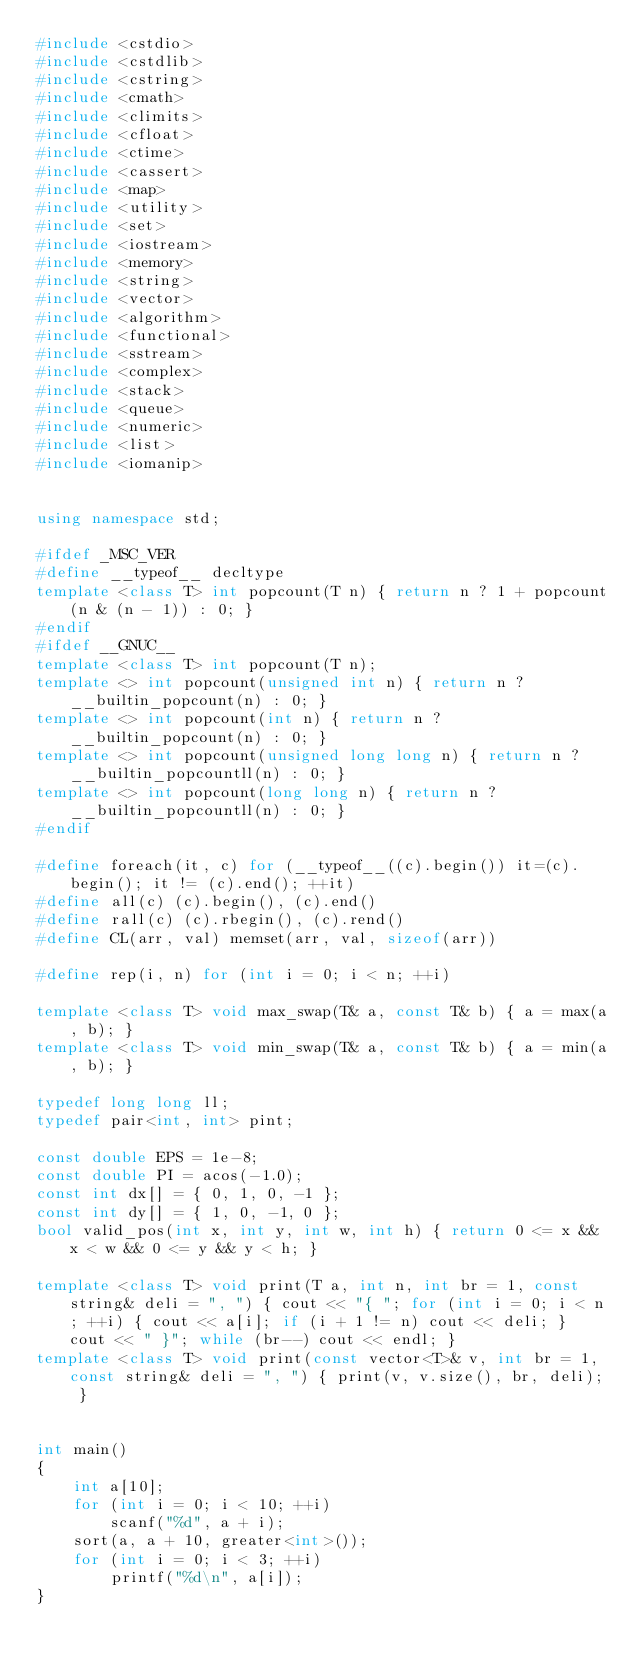<code> <loc_0><loc_0><loc_500><loc_500><_C++_>#include <cstdio>
#include <cstdlib>
#include <cstring>
#include <cmath>
#include <climits>
#include <cfloat>
#include <ctime>
#include <cassert>
#include <map>
#include <utility>
#include <set>
#include <iostream>
#include <memory>
#include <string>
#include <vector>
#include <algorithm>
#include <functional>
#include <sstream>
#include <complex>
#include <stack>
#include <queue>
#include <numeric>
#include <list>
#include <iomanip>


using namespace std;

#ifdef _MSC_VER
#define __typeof__ decltype
template <class T> int popcount(T n) { return n ? 1 + popcount(n & (n - 1)) : 0; }
#endif
#ifdef __GNUC__
template <class T> int popcount(T n);
template <> int popcount(unsigned int n) { return n ? __builtin_popcount(n) : 0; }
template <> int popcount(int n) { return n ? __builtin_popcount(n) : 0; }
template <> int popcount(unsigned long long n) { return n ? __builtin_popcountll(n) : 0; }
template <> int popcount(long long n) { return n ? __builtin_popcountll(n) : 0; }
#endif

#define foreach(it, c) for (__typeof__((c).begin()) it=(c).begin(); it != (c).end(); ++it)
#define all(c) (c).begin(), (c).end()
#define rall(c) (c).rbegin(), (c).rend()
#define CL(arr, val) memset(arr, val, sizeof(arr))

#define rep(i, n) for (int i = 0; i < n; ++i)

template <class T> void max_swap(T& a, const T& b) { a = max(a, b); }
template <class T> void min_swap(T& a, const T& b) { a = min(a, b); }

typedef long long ll;
typedef pair<int, int> pint;

const double EPS = 1e-8;
const double PI = acos(-1.0);
const int dx[] = { 0, 1, 0, -1 };
const int dy[] = { 1, 0, -1, 0 };
bool valid_pos(int x, int y, int w, int h) { return 0 <= x && x < w && 0 <= y && y < h; }

template <class T> void print(T a, int n, int br = 1, const string& deli = ", ") { cout << "{ "; for (int i = 0; i < n; ++i) { cout << a[i]; if (i + 1 != n) cout << deli; } cout << " }"; while (br--) cout << endl; }
template <class T> void print(const vector<T>& v, int br = 1, const string& deli = ", ") { print(v, v.size(), br, deli); }


int main()
{
	int a[10];
	for (int i = 0; i < 10; ++i)
		scanf("%d", a + i);
	sort(a, a + 10, greater<int>());
	for (int i = 0; i < 3; ++i)
		printf("%d\n", a[i]);
}</code> 